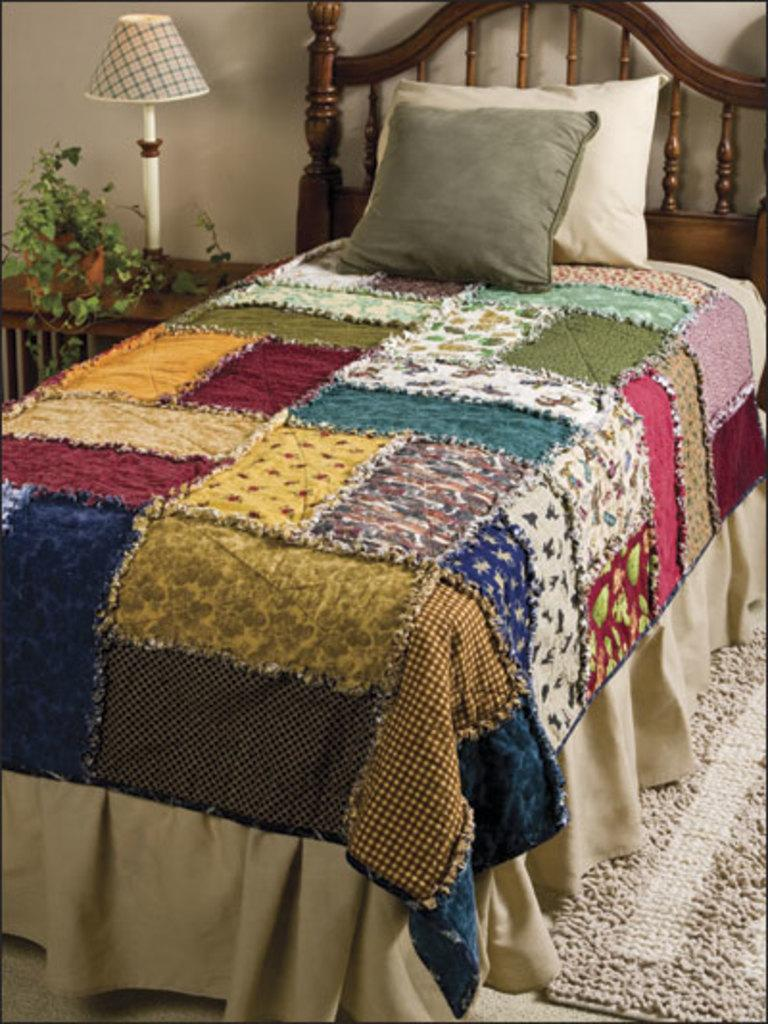What type of furniture is present in the image? There is a bed and a table in the image. What is the appearance of the bed sheet on the bed? The bed sheet on the bed is colorful. How many pillows are on the bed? There are 2 pillows on the bed. What can be found on the table in the image? There is a plant and a lamp on the table. What type of quill is used to water the plant on the table? There is no quill present in the image, and the plant is not being watered. How much powder is visible on the bed sheet in the image? There is no powder visible on the bed sheet in the image. 